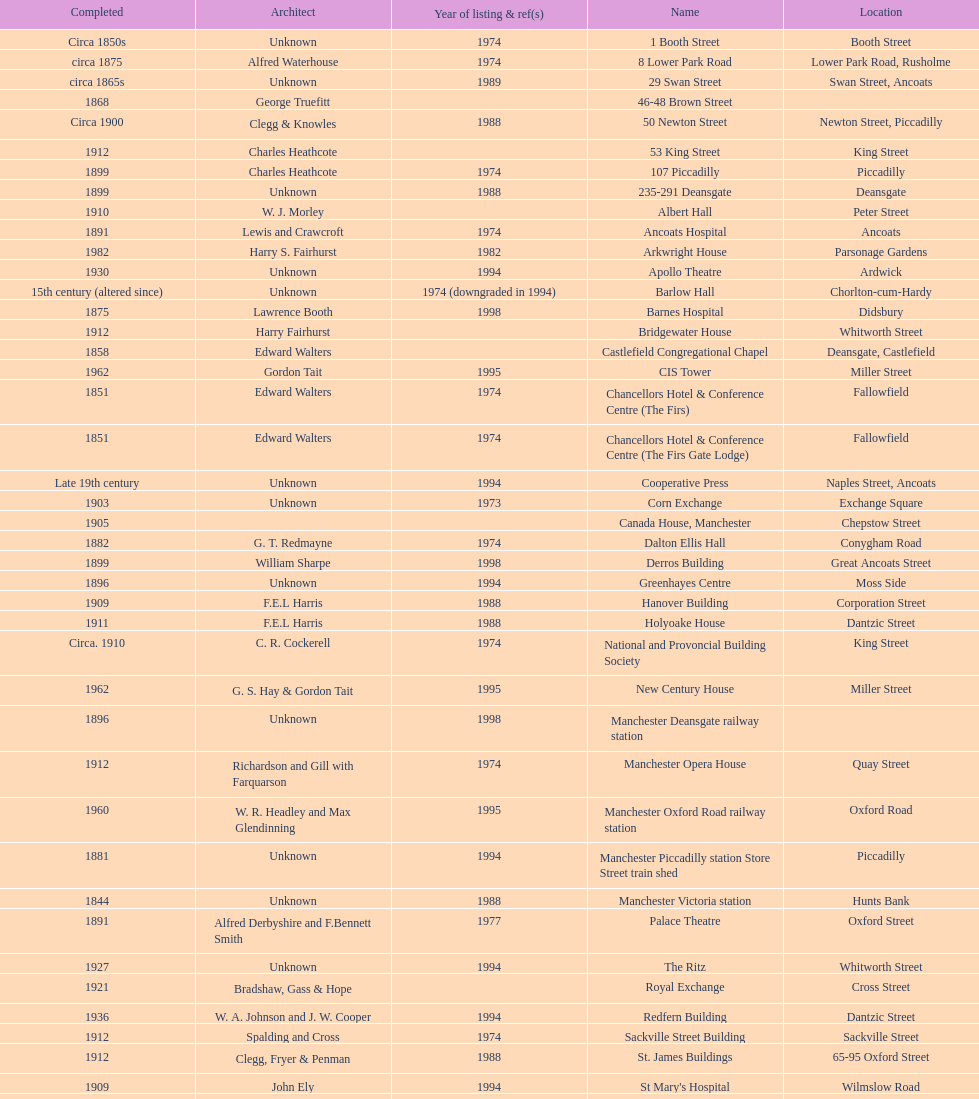What is the difference, in years, between the completion dates of 53 king street and castlefield congregational chapel? 54 years. 